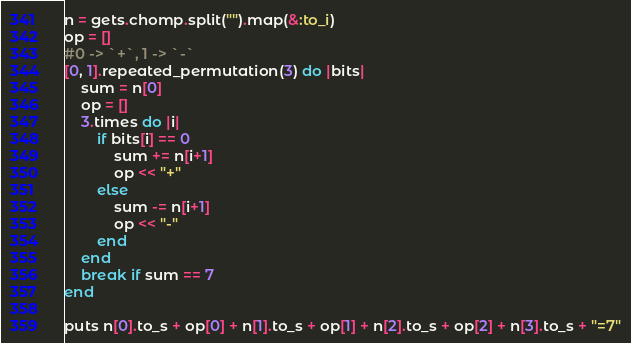<code> <loc_0><loc_0><loc_500><loc_500><_Ruby_>n = gets.chomp.split("").map(&:to_i)
op = []
#0 -> `+`, 1 -> `-`
[0, 1].repeated_permutation(3) do |bits|
    sum = n[0]
    op = []
    3.times do |i|
        if bits[i] == 0
            sum += n[i+1]
            op << "+"
        else
            sum -= n[i+1]
            op << "-"
        end
    end
    break if sum == 7
end

puts n[0].to_s + op[0] + n[1].to_s + op[1] + n[2].to_s + op[2] + n[3].to_s + "=7"</code> 